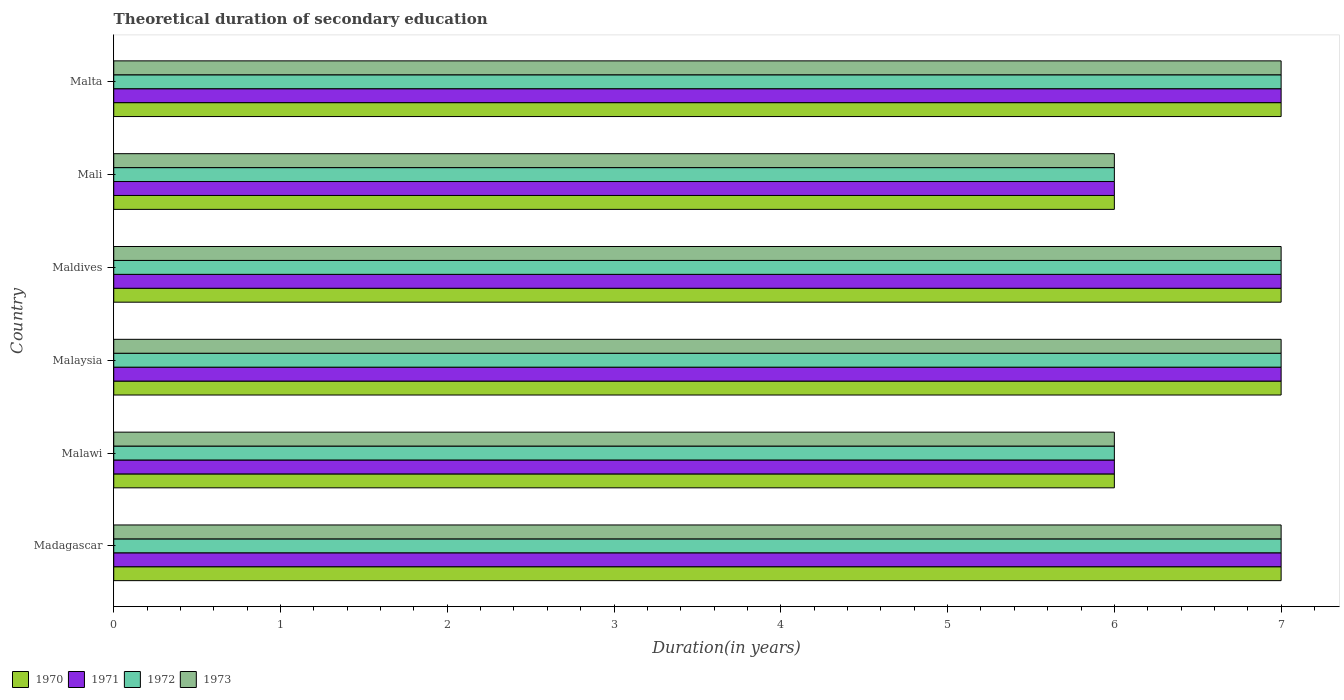How many groups of bars are there?
Your response must be concise. 6. Are the number of bars per tick equal to the number of legend labels?
Offer a very short reply. Yes. Are the number of bars on each tick of the Y-axis equal?
Your response must be concise. Yes. How many bars are there on the 5th tick from the top?
Your response must be concise. 4. How many bars are there on the 4th tick from the bottom?
Your answer should be very brief. 4. What is the label of the 5th group of bars from the top?
Offer a very short reply. Malawi. In how many cases, is the number of bars for a given country not equal to the number of legend labels?
Your answer should be compact. 0. Across all countries, what is the maximum total theoretical duration of secondary education in 1971?
Your answer should be compact. 7. In which country was the total theoretical duration of secondary education in 1970 maximum?
Your answer should be compact. Madagascar. In which country was the total theoretical duration of secondary education in 1970 minimum?
Your answer should be compact. Malawi. What is the total total theoretical duration of secondary education in 1971 in the graph?
Your answer should be very brief. 40. What is the difference between the total theoretical duration of secondary education in 1972 in Maldives and the total theoretical duration of secondary education in 1971 in Madagascar?
Your answer should be very brief. 0. What is the average total theoretical duration of secondary education in 1971 per country?
Provide a succinct answer. 6.67. What is the difference between the total theoretical duration of secondary education in 1972 and total theoretical duration of secondary education in 1970 in Malta?
Offer a very short reply. 0. In how many countries, is the total theoretical duration of secondary education in 1972 greater than 2.4 years?
Keep it short and to the point. 6. What is the ratio of the total theoretical duration of secondary education in 1970 in Madagascar to that in Mali?
Your response must be concise. 1.17. Is the total theoretical duration of secondary education in 1972 in Madagascar less than that in Malaysia?
Make the answer very short. No. Is the difference between the total theoretical duration of secondary education in 1972 in Malaysia and Mali greater than the difference between the total theoretical duration of secondary education in 1970 in Malaysia and Mali?
Provide a succinct answer. No. What is the difference between the highest and the lowest total theoretical duration of secondary education in 1972?
Offer a very short reply. 1. What does the 1st bar from the bottom in Malta represents?
Your answer should be compact. 1970. How many bars are there?
Your response must be concise. 24. How many countries are there in the graph?
Keep it short and to the point. 6. Does the graph contain any zero values?
Provide a succinct answer. No. Where does the legend appear in the graph?
Provide a succinct answer. Bottom left. How are the legend labels stacked?
Give a very brief answer. Horizontal. What is the title of the graph?
Make the answer very short. Theoretical duration of secondary education. Does "1987" appear as one of the legend labels in the graph?
Your answer should be very brief. No. What is the label or title of the X-axis?
Ensure brevity in your answer.  Duration(in years). What is the Duration(in years) in 1972 in Madagascar?
Provide a succinct answer. 7. What is the Duration(in years) of 1973 in Madagascar?
Keep it short and to the point. 7. What is the Duration(in years) of 1971 in Malawi?
Your response must be concise. 6. What is the Duration(in years) of 1973 in Malawi?
Your response must be concise. 6. What is the Duration(in years) in 1973 in Malaysia?
Ensure brevity in your answer.  7. What is the Duration(in years) in 1971 in Maldives?
Make the answer very short. 7. What is the Duration(in years) of 1971 in Mali?
Provide a succinct answer. 6. What is the Duration(in years) in 1972 in Mali?
Provide a succinct answer. 6. What is the Duration(in years) of 1971 in Malta?
Your answer should be very brief. 7. Across all countries, what is the maximum Duration(in years) in 1970?
Provide a short and direct response. 7. Across all countries, what is the maximum Duration(in years) in 1972?
Keep it short and to the point. 7. Across all countries, what is the minimum Duration(in years) in 1970?
Give a very brief answer. 6. What is the total Duration(in years) in 1971 in the graph?
Keep it short and to the point. 40. What is the total Duration(in years) of 1972 in the graph?
Offer a very short reply. 40. What is the total Duration(in years) in 1973 in the graph?
Give a very brief answer. 40. What is the difference between the Duration(in years) in 1970 in Madagascar and that in Malawi?
Provide a short and direct response. 1. What is the difference between the Duration(in years) of 1972 in Madagascar and that in Malawi?
Offer a terse response. 1. What is the difference between the Duration(in years) of 1973 in Madagascar and that in Malawi?
Give a very brief answer. 1. What is the difference between the Duration(in years) of 1970 in Madagascar and that in Malaysia?
Your answer should be very brief. 0. What is the difference between the Duration(in years) of 1971 in Madagascar and that in Malaysia?
Give a very brief answer. 0. What is the difference between the Duration(in years) of 1973 in Madagascar and that in Malaysia?
Provide a succinct answer. 0. What is the difference between the Duration(in years) in 1972 in Madagascar and that in Maldives?
Make the answer very short. 0. What is the difference between the Duration(in years) in 1973 in Madagascar and that in Maldives?
Your response must be concise. 0. What is the difference between the Duration(in years) of 1971 in Madagascar and that in Mali?
Offer a very short reply. 1. What is the difference between the Duration(in years) in 1972 in Madagascar and that in Mali?
Your answer should be very brief. 1. What is the difference between the Duration(in years) of 1973 in Madagascar and that in Mali?
Your answer should be compact. 1. What is the difference between the Duration(in years) in 1970 in Madagascar and that in Malta?
Your answer should be very brief. 0. What is the difference between the Duration(in years) of 1971 in Madagascar and that in Malta?
Offer a very short reply. 0. What is the difference between the Duration(in years) in 1973 in Madagascar and that in Malta?
Your answer should be compact. 0. What is the difference between the Duration(in years) of 1971 in Malawi and that in Maldives?
Keep it short and to the point. -1. What is the difference between the Duration(in years) in 1970 in Malawi and that in Mali?
Offer a terse response. 0. What is the difference between the Duration(in years) of 1973 in Malawi and that in Mali?
Your response must be concise. 0. What is the difference between the Duration(in years) in 1970 in Malawi and that in Malta?
Provide a short and direct response. -1. What is the difference between the Duration(in years) in 1972 in Malawi and that in Malta?
Offer a very short reply. -1. What is the difference between the Duration(in years) of 1973 in Malawi and that in Malta?
Your response must be concise. -1. What is the difference between the Duration(in years) in 1972 in Malaysia and that in Maldives?
Ensure brevity in your answer.  0. What is the difference between the Duration(in years) in 1970 in Malaysia and that in Mali?
Your answer should be compact. 1. What is the difference between the Duration(in years) in 1971 in Malaysia and that in Mali?
Ensure brevity in your answer.  1. What is the difference between the Duration(in years) in 1972 in Malaysia and that in Mali?
Your answer should be very brief. 1. What is the difference between the Duration(in years) in 1972 in Malaysia and that in Malta?
Offer a very short reply. 0. What is the difference between the Duration(in years) in 1973 in Malaysia and that in Malta?
Keep it short and to the point. 0. What is the difference between the Duration(in years) of 1970 in Maldives and that in Malta?
Offer a terse response. 0. What is the difference between the Duration(in years) in 1972 in Maldives and that in Malta?
Make the answer very short. 0. What is the difference between the Duration(in years) of 1970 in Mali and that in Malta?
Your response must be concise. -1. What is the difference between the Duration(in years) of 1970 in Madagascar and the Duration(in years) of 1972 in Malawi?
Offer a very short reply. 1. What is the difference between the Duration(in years) in 1970 in Madagascar and the Duration(in years) in 1973 in Malawi?
Make the answer very short. 1. What is the difference between the Duration(in years) of 1971 in Madagascar and the Duration(in years) of 1972 in Malawi?
Provide a succinct answer. 1. What is the difference between the Duration(in years) of 1970 in Madagascar and the Duration(in years) of 1973 in Malaysia?
Provide a succinct answer. 0. What is the difference between the Duration(in years) in 1971 in Madagascar and the Duration(in years) in 1973 in Malaysia?
Provide a short and direct response. 0. What is the difference between the Duration(in years) in 1970 in Madagascar and the Duration(in years) in 1973 in Maldives?
Keep it short and to the point. 0. What is the difference between the Duration(in years) in 1971 in Madagascar and the Duration(in years) in 1973 in Maldives?
Your response must be concise. 0. What is the difference between the Duration(in years) of 1970 in Madagascar and the Duration(in years) of 1972 in Mali?
Give a very brief answer. 1. What is the difference between the Duration(in years) of 1970 in Madagascar and the Duration(in years) of 1973 in Mali?
Provide a succinct answer. 1. What is the difference between the Duration(in years) of 1971 in Madagascar and the Duration(in years) of 1972 in Mali?
Your answer should be compact. 1. What is the difference between the Duration(in years) of 1971 in Madagascar and the Duration(in years) of 1973 in Mali?
Keep it short and to the point. 1. What is the difference between the Duration(in years) in 1972 in Madagascar and the Duration(in years) in 1973 in Mali?
Your answer should be compact. 1. What is the difference between the Duration(in years) of 1970 in Madagascar and the Duration(in years) of 1971 in Malta?
Offer a terse response. 0. What is the difference between the Duration(in years) in 1970 in Madagascar and the Duration(in years) in 1972 in Malta?
Your response must be concise. 0. What is the difference between the Duration(in years) in 1971 in Malawi and the Duration(in years) in 1972 in Malaysia?
Your answer should be very brief. -1. What is the difference between the Duration(in years) of 1972 in Malawi and the Duration(in years) of 1973 in Malaysia?
Ensure brevity in your answer.  -1. What is the difference between the Duration(in years) in 1970 in Malawi and the Duration(in years) in 1971 in Maldives?
Your answer should be compact. -1. What is the difference between the Duration(in years) in 1970 in Malawi and the Duration(in years) in 1972 in Maldives?
Give a very brief answer. -1. What is the difference between the Duration(in years) in 1971 in Malawi and the Duration(in years) in 1972 in Maldives?
Provide a short and direct response. -1. What is the difference between the Duration(in years) in 1971 in Malawi and the Duration(in years) in 1973 in Maldives?
Ensure brevity in your answer.  -1. What is the difference between the Duration(in years) in 1972 in Malawi and the Duration(in years) in 1973 in Maldives?
Your response must be concise. -1. What is the difference between the Duration(in years) in 1970 in Malawi and the Duration(in years) in 1971 in Mali?
Provide a short and direct response. 0. What is the difference between the Duration(in years) in 1970 in Malawi and the Duration(in years) in 1972 in Mali?
Your answer should be very brief. 0. What is the difference between the Duration(in years) of 1970 in Malawi and the Duration(in years) of 1973 in Mali?
Make the answer very short. 0. What is the difference between the Duration(in years) in 1971 in Malawi and the Duration(in years) in 1972 in Mali?
Provide a short and direct response. 0. What is the difference between the Duration(in years) of 1971 in Malawi and the Duration(in years) of 1973 in Mali?
Your response must be concise. 0. What is the difference between the Duration(in years) in 1970 in Malawi and the Duration(in years) in 1971 in Malta?
Make the answer very short. -1. What is the difference between the Duration(in years) in 1971 in Malawi and the Duration(in years) in 1973 in Malta?
Your answer should be very brief. -1. What is the difference between the Duration(in years) in 1972 in Malawi and the Duration(in years) in 1973 in Malta?
Offer a very short reply. -1. What is the difference between the Duration(in years) of 1970 in Malaysia and the Duration(in years) of 1971 in Maldives?
Your answer should be compact. 0. What is the difference between the Duration(in years) in 1971 in Malaysia and the Duration(in years) in 1972 in Maldives?
Ensure brevity in your answer.  0. What is the difference between the Duration(in years) in 1971 in Malaysia and the Duration(in years) in 1973 in Maldives?
Offer a terse response. 0. What is the difference between the Duration(in years) in 1972 in Malaysia and the Duration(in years) in 1973 in Maldives?
Give a very brief answer. 0. What is the difference between the Duration(in years) in 1970 in Malaysia and the Duration(in years) in 1971 in Mali?
Provide a succinct answer. 1. What is the difference between the Duration(in years) in 1970 in Malaysia and the Duration(in years) in 1973 in Mali?
Keep it short and to the point. 1. What is the difference between the Duration(in years) in 1971 in Malaysia and the Duration(in years) in 1972 in Mali?
Provide a short and direct response. 1. What is the difference between the Duration(in years) of 1970 in Malaysia and the Duration(in years) of 1973 in Malta?
Your response must be concise. 0. What is the difference between the Duration(in years) in 1971 in Malaysia and the Duration(in years) in 1972 in Malta?
Give a very brief answer. 0. What is the difference between the Duration(in years) of 1971 in Malaysia and the Duration(in years) of 1973 in Malta?
Your answer should be compact. 0. What is the difference between the Duration(in years) of 1972 in Malaysia and the Duration(in years) of 1973 in Malta?
Offer a terse response. 0. What is the difference between the Duration(in years) in 1970 in Maldives and the Duration(in years) in 1972 in Mali?
Provide a succinct answer. 1. What is the difference between the Duration(in years) in 1971 in Maldives and the Duration(in years) in 1973 in Mali?
Your response must be concise. 1. What is the difference between the Duration(in years) in 1972 in Maldives and the Duration(in years) in 1973 in Mali?
Your response must be concise. 1. What is the difference between the Duration(in years) of 1970 in Maldives and the Duration(in years) of 1971 in Malta?
Keep it short and to the point. 0. What is the difference between the Duration(in years) of 1971 in Mali and the Duration(in years) of 1972 in Malta?
Keep it short and to the point. -1. What is the average Duration(in years) in 1970 per country?
Offer a terse response. 6.67. What is the average Duration(in years) in 1973 per country?
Your answer should be very brief. 6.67. What is the difference between the Duration(in years) of 1970 and Duration(in years) of 1971 in Madagascar?
Offer a very short reply. 0. What is the difference between the Duration(in years) of 1970 and Duration(in years) of 1972 in Madagascar?
Provide a succinct answer. 0. What is the difference between the Duration(in years) in 1970 and Duration(in years) in 1973 in Madagascar?
Make the answer very short. 0. What is the difference between the Duration(in years) of 1971 and Duration(in years) of 1972 in Madagascar?
Provide a succinct answer. 0. What is the difference between the Duration(in years) of 1971 and Duration(in years) of 1973 in Madagascar?
Make the answer very short. 0. What is the difference between the Duration(in years) in 1972 and Duration(in years) in 1973 in Madagascar?
Ensure brevity in your answer.  0. What is the difference between the Duration(in years) in 1971 and Duration(in years) in 1973 in Malawi?
Your answer should be compact. 0. What is the difference between the Duration(in years) of 1970 and Duration(in years) of 1971 in Malaysia?
Offer a very short reply. 0. What is the difference between the Duration(in years) in 1971 and Duration(in years) in 1972 in Malaysia?
Provide a succinct answer. 0. What is the difference between the Duration(in years) in 1972 and Duration(in years) in 1973 in Malaysia?
Your answer should be very brief. 0. What is the difference between the Duration(in years) of 1970 and Duration(in years) of 1973 in Maldives?
Provide a short and direct response. 0. What is the difference between the Duration(in years) in 1970 and Duration(in years) in 1973 in Mali?
Make the answer very short. 0. What is the difference between the Duration(in years) in 1971 and Duration(in years) in 1972 in Mali?
Keep it short and to the point. 0. What is the difference between the Duration(in years) of 1972 and Duration(in years) of 1973 in Mali?
Provide a short and direct response. 0. What is the difference between the Duration(in years) in 1970 and Duration(in years) in 1971 in Malta?
Make the answer very short. 0. What is the difference between the Duration(in years) in 1970 and Duration(in years) in 1973 in Malta?
Give a very brief answer. 0. What is the ratio of the Duration(in years) of 1971 in Madagascar to that in Malawi?
Your answer should be very brief. 1.17. What is the ratio of the Duration(in years) in 1971 in Madagascar to that in Malaysia?
Make the answer very short. 1. What is the ratio of the Duration(in years) in 1971 in Madagascar to that in Maldives?
Offer a very short reply. 1. What is the ratio of the Duration(in years) of 1972 in Madagascar to that in Maldives?
Your answer should be compact. 1. What is the ratio of the Duration(in years) in 1973 in Madagascar to that in Maldives?
Your response must be concise. 1. What is the ratio of the Duration(in years) in 1971 in Madagascar to that in Mali?
Your response must be concise. 1.17. What is the ratio of the Duration(in years) in 1972 in Madagascar to that in Mali?
Offer a very short reply. 1.17. What is the ratio of the Duration(in years) in 1970 in Madagascar to that in Malta?
Keep it short and to the point. 1. What is the ratio of the Duration(in years) of 1973 in Madagascar to that in Malta?
Provide a succinct answer. 1. What is the ratio of the Duration(in years) in 1970 in Malawi to that in Malaysia?
Provide a short and direct response. 0.86. What is the ratio of the Duration(in years) of 1970 in Malawi to that in Maldives?
Keep it short and to the point. 0.86. What is the ratio of the Duration(in years) of 1972 in Malawi to that in Maldives?
Give a very brief answer. 0.86. What is the ratio of the Duration(in years) of 1973 in Malawi to that in Maldives?
Offer a very short reply. 0.86. What is the ratio of the Duration(in years) in 1970 in Malawi to that in Mali?
Provide a succinct answer. 1. What is the ratio of the Duration(in years) of 1971 in Malawi to that in Mali?
Ensure brevity in your answer.  1. What is the ratio of the Duration(in years) of 1972 in Malawi to that in Mali?
Offer a terse response. 1. What is the ratio of the Duration(in years) in 1971 in Malawi to that in Malta?
Offer a very short reply. 0.86. What is the ratio of the Duration(in years) of 1973 in Malawi to that in Malta?
Provide a succinct answer. 0.86. What is the ratio of the Duration(in years) in 1971 in Malaysia to that in Maldives?
Keep it short and to the point. 1. What is the ratio of the Duration(in years) in 1972 in Malaysia to that in Maldives?
Your answer should be very brief. 1. What is the ratio of the Duration(in years) in 1971 in Malaysia to that in Mali?
Offer a terse response. 1.17. What is the ratio of the Duration(in years) in 1972 in Malaysia to that in Mali?
Your response must be concise. 1.17. What is the ratio of the Duration(in years) of 1973 in Malaysia to that in Mali?
Offer a very short reply. 1.17. What is the ratio of the Duration(in years) of 1970 in Malaysia to that in Malta?
Your answer should be compact. 1. What is the ratio of the Duration(in years) of 1972 in Malaysia to that in Malta?
Offer a very short reply. 1. What is the ratio of the Duration(in years) of 1973 in Malaysia to that in Malta?
Give a very brief answer. 1. What is the ratio of the Duration(in years) in 1970 in Maldives to that in Mali?
Offer a very short reply. 1.17. What is the ratio of the Duration(in years) of 1973 in Maldives to that in Mali?
Keep it short and to the point. 1.17. What is the ratio of the Duration(in years) of 1970 in Maldives to that in Malta?
Make the answer very short. 1. What is the ratio of the Duration(in years) of 1971 in Maldives to that in Malta?
Keep it short and to the point. 1. What is the ratio of the Duration(in years) in 1970 in Mali to that in Malta?
Offer a terse response. 0.86. What is the ratio of the Duration(in years) of 1971 in Mali to that in Malta?
Your answer should be compact. 0.86. What is the ratio of the Duration(in years) in 1973 in Mali to that in Malta?
Your answer should be compact. 0.86. What is the difference between the highest and the second highest Duration(in years) in 1970?
Your response must be concise. 0. What is the difference between the highest and the second highest Duration(in years) of 1972?
Your answer should be compact. 0. What is the difference between the highest and the lowest Duration(in years) of 1972?
Keep it short and to the point. 1. What is the difference between the highest and the lowest Duration(in years) in 1973?
Offer a terse response. 1. 